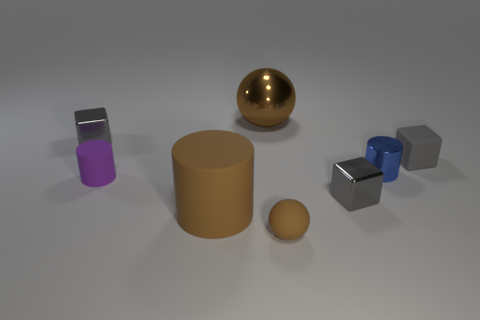Subtract all red blocks. Subtract all gray spheres. How many blocks are left? 3 Add 1 tiny green cubes. How many objects exist? 9 Subtract all cylinders. How many objects are left? 5 Subtract all tiny purple matte spheres. Subtract all big brown things. How many objects are left? 6 Add 8 gray rubber blocks. How many gray rubber blocks are left? 9 Add 2 brown objects. How many brown objects exist? 5 Subtract 0 cyan cylinders. How many objects are left? 8 